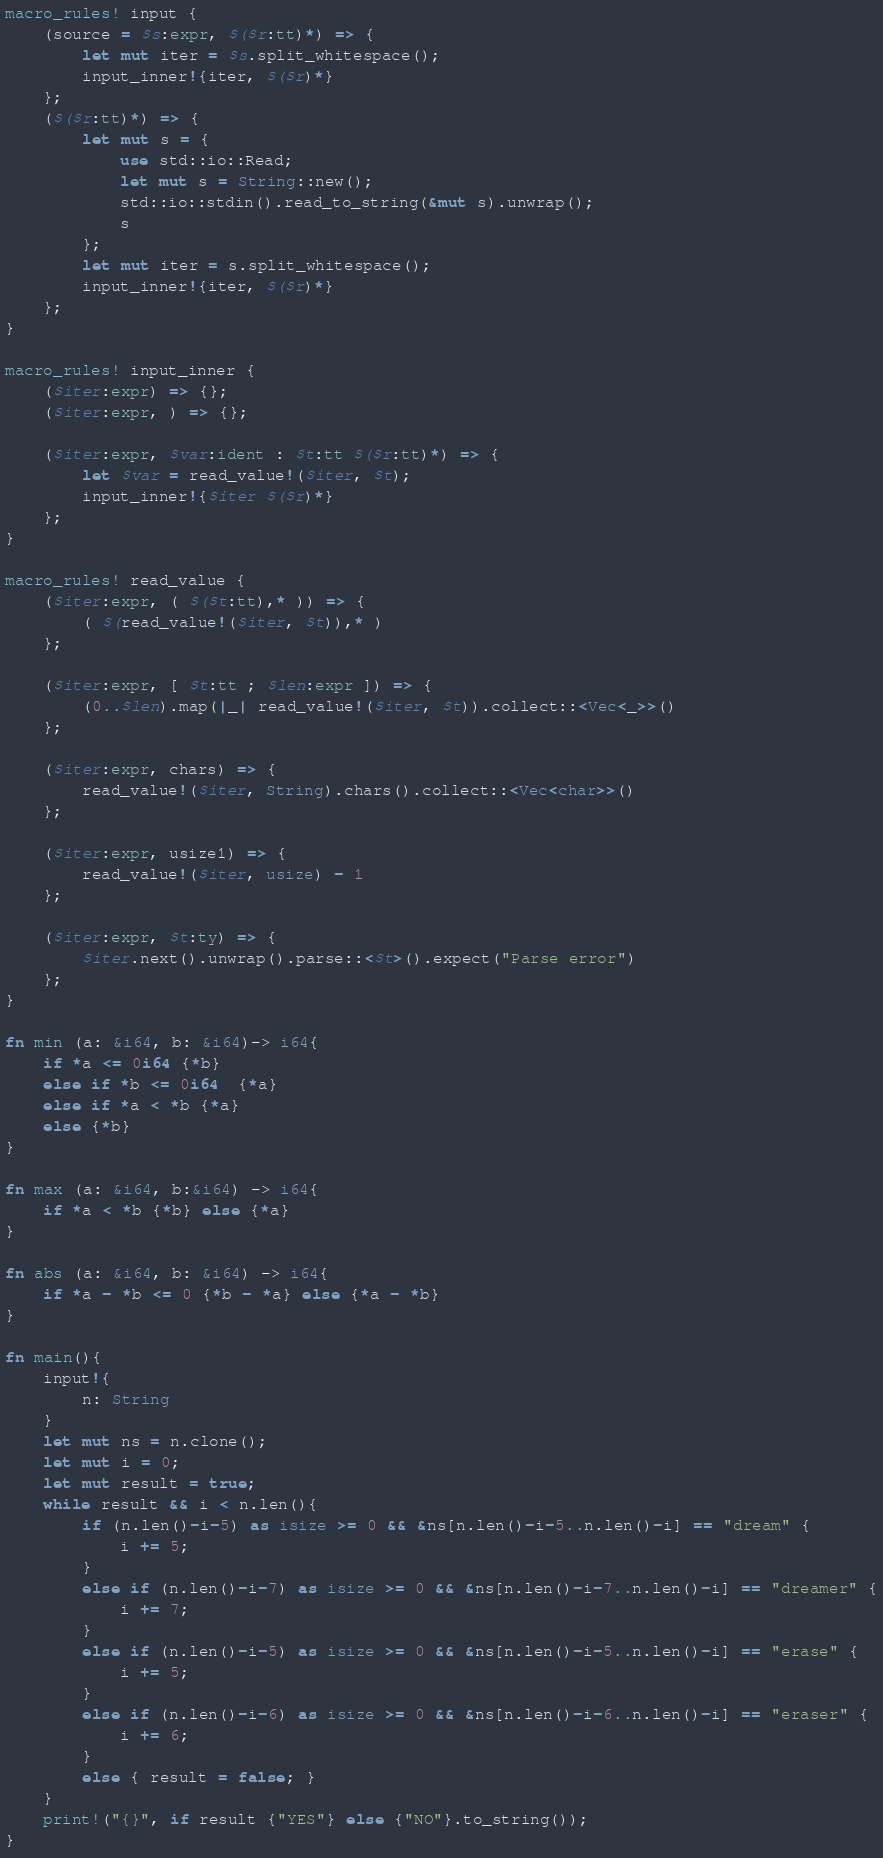<code> <loc_0><loc_0><loc_500><loc_500><_Rust_>macro_rules! input {
    (source = $s:expr, $($r:tt)*) => {
        let mut iter = $s.split_whitespace();
        input_inner!{iter, $($r)*}
    };
    ($($r:tt)*) => {
        let mut s = {
            use std::io::Read;
            let mut s = String::new();
            std::io::stdin().read_to_string(&mut s).unwrap();
            s
        };
        let mut iter = s.split_whitespace();
        input_inner!{iter, $($r)*}
    };
}

macro_rules! input_inner {
    ($iter:expr) => {};
    ($iter:expr, ) => {};

    ($iter:expr, $var:ident : $t:tt $($r:tt)*) => {
        let $var = read_value!($iter, $t);
        input_inner!{$iter $($r)*}
    };
}

macro_rules! read_value {
    ($iter:expr, ( $($t:tt),* )) => {
        ( $(read_value!($iter, $t)),* )
    };

    ($iter:expr, [ $t:tt ; $len:expr ]) => {
        (0..$len).map(|_| read_value!($iter, $t)).collect::<Vec<_>>()
    };

    ($iter:expr, chars) => {
        read_value!($iter, String).chars().collect::<Vec<char>>()
    };

    ($iter:expr, usize1) => {
        read_value!($iter, usize) - 1
    };

    ($iter:expr, $t:ty) => {
        $iter.next().unwrap().parse::<$t>().expect("Parse error")
    };
}

fn min (a: &i64, b: &i64)-> i64{
    if *a <= 0i64 {*b}
    else if *b <= 0i64  {*a}
    else if *a < *b {*a}
    else {*b}
}

fn max (a: &i64, b:&i64) -> i64{
    if *a < *b {*b} else {*a}
}

fn abs (a: &i64, b: &i64) -> i64{
    if *a - *b <= 0 {*b - *a} else {*a - *b}
}

fn main(){
    input!{
        n: String
    }
    let mut ns = n.clone();
    let mut i = 0;
    let mut result = true;
    while result && i < n.len(){
        if (n.len()-i-5) as isize >= 0 && &ns[n.len()-i-5..n.len()-i] == "dream" {
            i += 5;
        }
        else if (n.len()-i-7) as isize >= 0 && &ns[n.len()-i-7..n.len()-i] == "dreamer" {
            i += 7;
        }
        else if (n.len()-i-5) as isize >= 0 && &ns[n.len()-i-5..n.len()-i] == "erase" {
            i += 5;
        }
        else if (n.len()-i-6) as isize >= 0 && &ns[n.len()-i-6..n.len()-i] == "eraser" {
            i += 6;
        }
        else { result = false; }
    }
    print!("{}", if result {"YES"} else {"NO"}.to_string());
}
</code> 